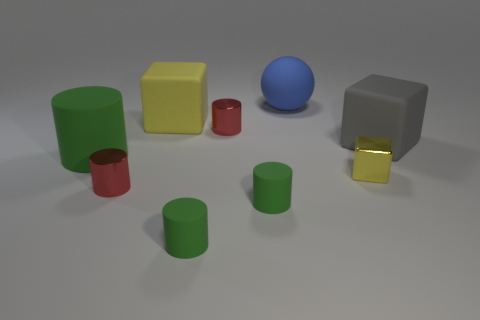Subtract all green matte cylinders. How many cylinders are left? 2 Subtract all red cylinders. How many cylinders are left? 3 Add 5 yellow rubber blocks. How many yellow rubber blocks are left? 6 Add 2 red metallic cubes. How many red metallic cubes exist? 2 Subtract 0 cyan cylinders. How many objects are left? 9 Subtract all spheres. How many objects are left? 8 Subtract 1 cubes. How many cubes are left? 2 Subtract all gray spheres. Subtract all brown blocks. How many spheres are left? 1 Subtract all brown cubes. How many green cylinders are left? 3 Subtract all small matte cylinders. Subtract all large blue rubber balls. How many objects are left? 6 